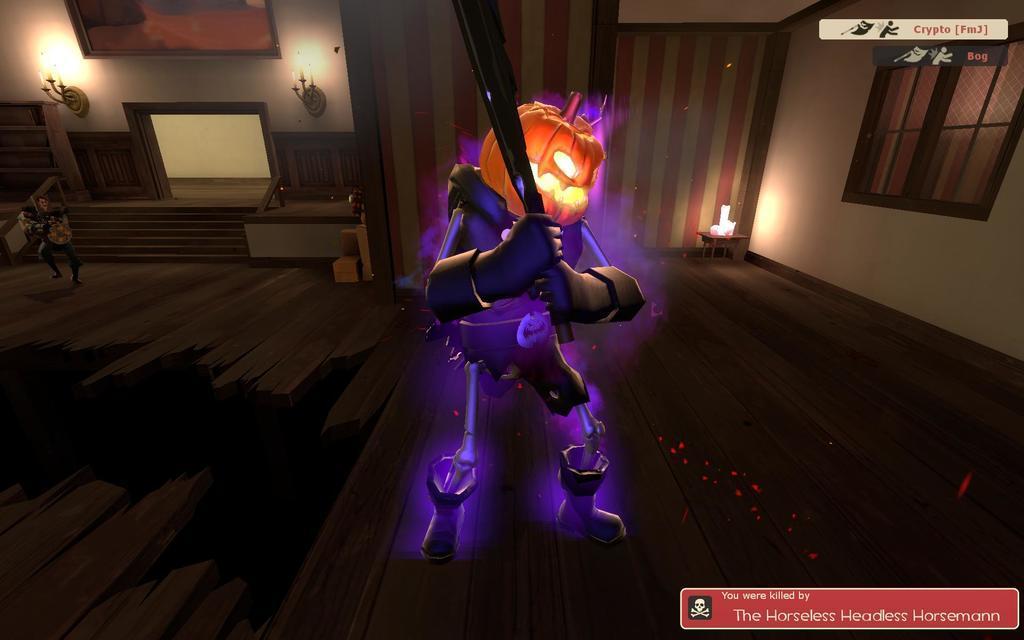Can you describe this image briefly? This is a graphic image of a robot with pumpkin face standing in the middle of living room, a man walking on the left side in front of steps. 